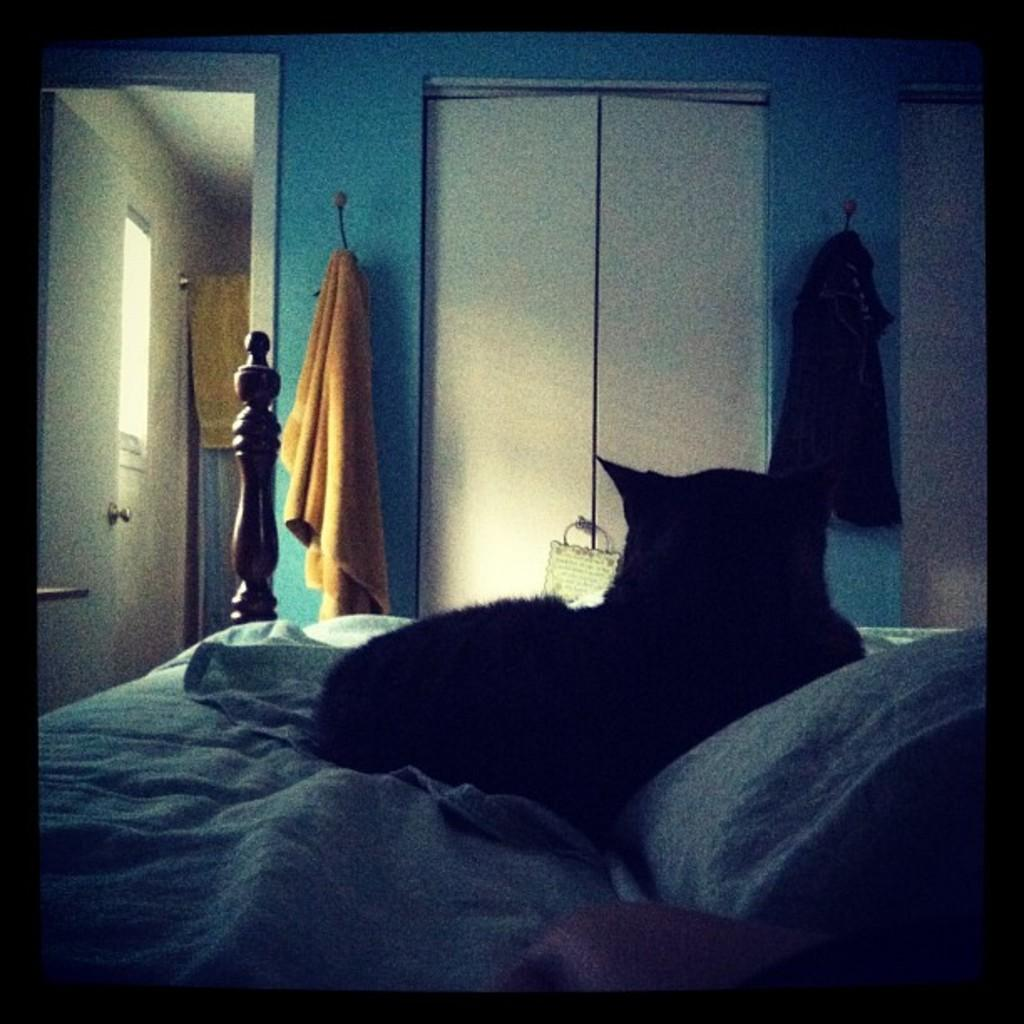Where is the setting of the image? The image is inside a room. What can be seen on the bed in the image? There is a cat laying on the bed. Is there any entrance or exit in the room? Yes, there is a door in the room. Can you describe any item related to personal hygiene or cleaning in the image? There is a towel hanging on a hanger. What type of lace can be seen on the cat's collar in the image? There is no lace or collar visible on the cat in the image. What kind of drink is the cat holding in its paw in the image? Cats do not hold drinks, and there is no drink present in the image. 